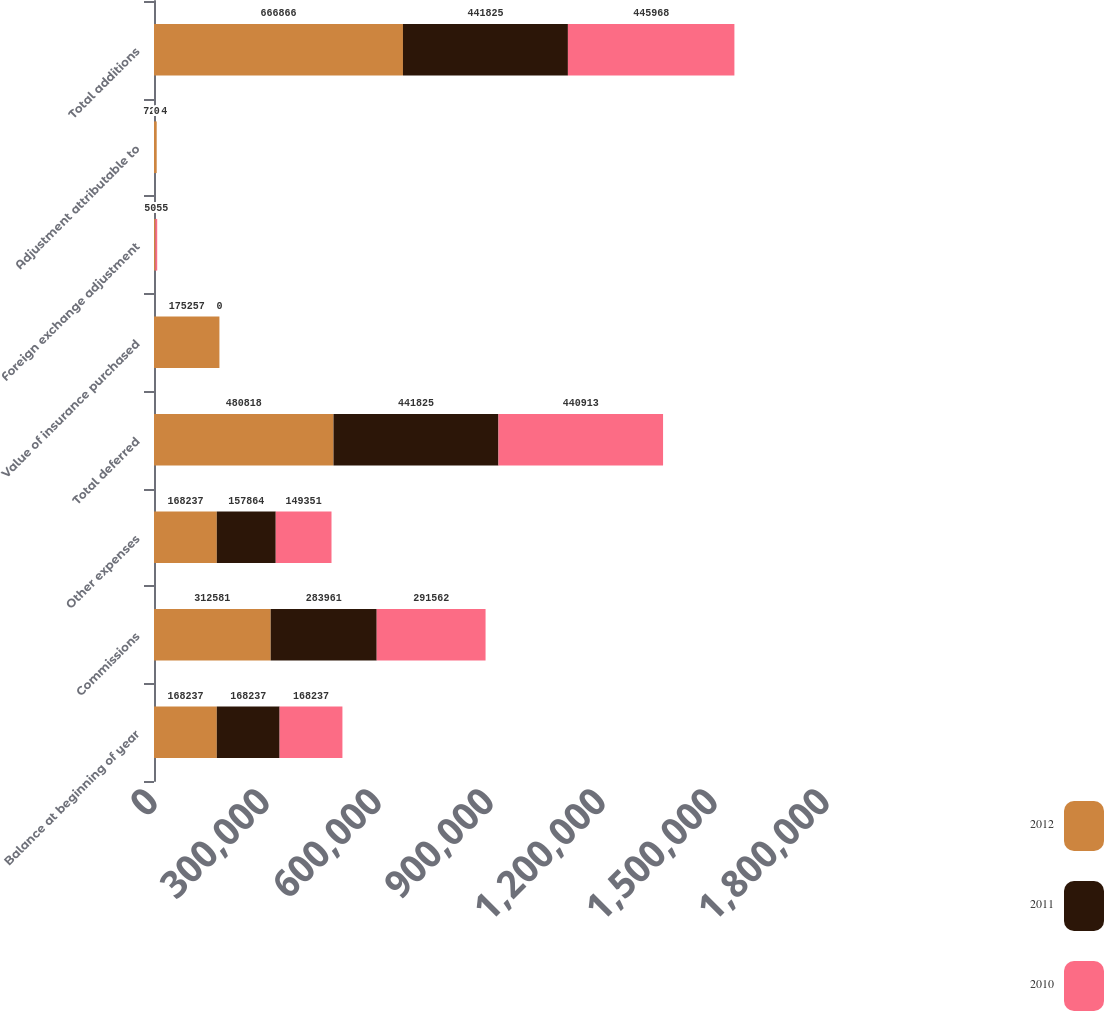Convert chart. <chart><loc_0><loc_0><loc_500><loc_500><stacked_bar_chart><ecel><fcel>Balance at beginning of year<fcel>Commissions<fcel>Other expenses<fcel>Total deferred<fcel>Value of insurance purchased<fcel>Foreign exchange adjustment<fcel>Adjustment attributable to<fcel>Total additions<nl><fcel>2012<fcel>168237<fcel>312581<fcel>168237<fcel>480818<fcel>175257<fcel>3557<fcel>7234<fcel>666866<nl><fcel>2011<fcel>168237<fcel>283961<fcel>157864<fcel>441825<fcel>0<fcel>0<fcel>0<fcel>441825<nl><fcel>2010<fcel>168237<fcel>291562<fcel>149351<fcel>440913<fcel>0<fcel>5055<fcel>0<fcel>445968<nl></chart> 